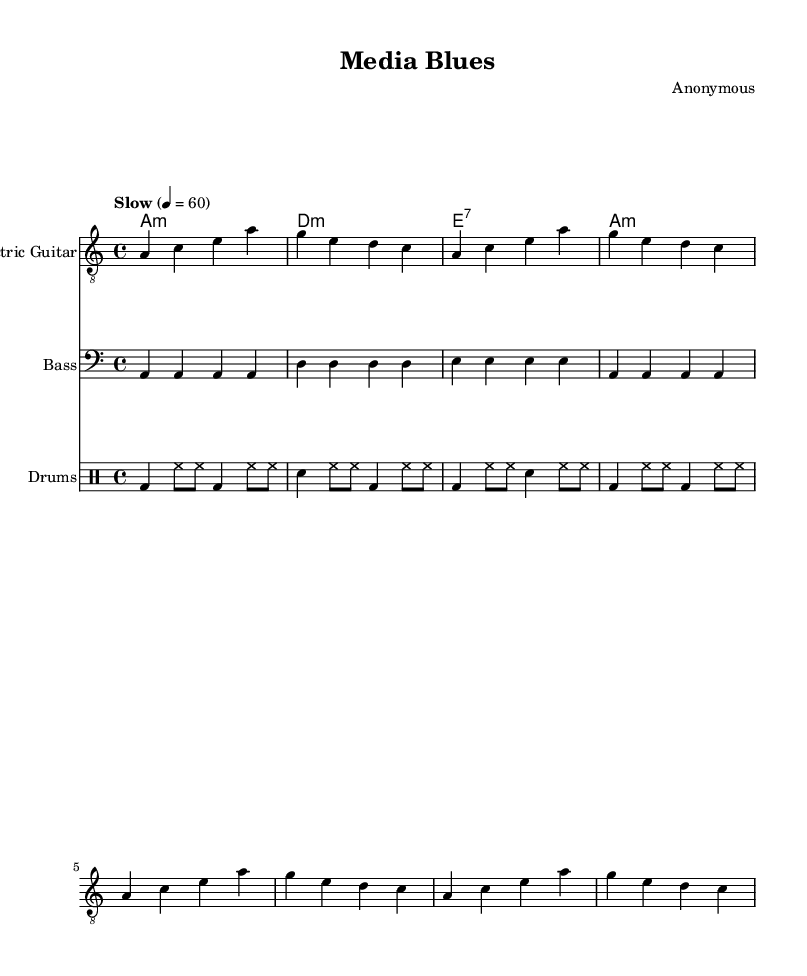What is the key signature of this music? The key signature is A minor, which is indicated by having no sharps or flats in the key signature area at the beginning of the staff. This can be deduced from the context of the notes being played, as A minor is the relative minor of C major.
Answer: A minor What is the time signature of this music? The time signature is 4/4, which is shown at the beginning of the staff. This indicates that there are four beats in each measure and the quarter note gets one beat.
Answer: 4/4 What is the tempo marking of this music? The tempo marking is "Slow", indicated above the staff with a quarter note equaling 60 beats per minute. This helps musicians know how quickly to play the piece.
Answer: Slow How many measures does the Electric Guitar part have? The Electric Guitar part consists of four measures, which is evident by counting the groups of vertical lines (bar lines) that separate each measure in the music.
Answer: Four What type of seventh chord is used in this music? The chord indicated is an E7, as derived from the chord symbol in the chord section. E7 is a dominant seventh chord, consisting of the root (E), major third (G#), perfect fifth (B), and minor seventh (D).
Answer: E7 Which instruments are included in this score? The score includes three instruments: Electric Guitar, Bass, and Drums. This is indicated by the instrument names at the beginning of each staff.
Answer: Electric Guitar, Bass, Drums What musical genre does this piece represent? The genre is Electric Blues, which can be inferred from the music's mood, structure, and instrumentation that highlights electric guitar and rhythmic elements typical of blues music.
Answer: Electric Blues 